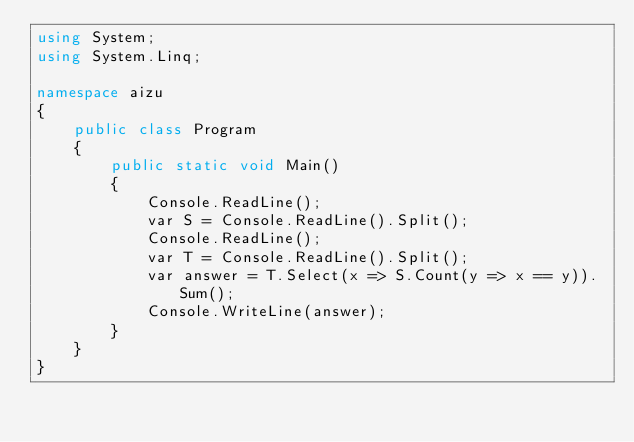<code> <loc_0><loc_0><loc_500><loc_500><_C#_>using System;
using System.Linq;

namespace aizu
{
    public class Program
    {
        public static void Main()
        {
            Console.ReadLine();
            var S = Console.ReadLine().Split();
            Console.ReadLine();
            var T = Console.ReadLine().Split();
            var answer = T.Select(x => S.Count(y => x == y)).Sum();
            Console.WriteLine(answer);
        }
    }
}</code> 